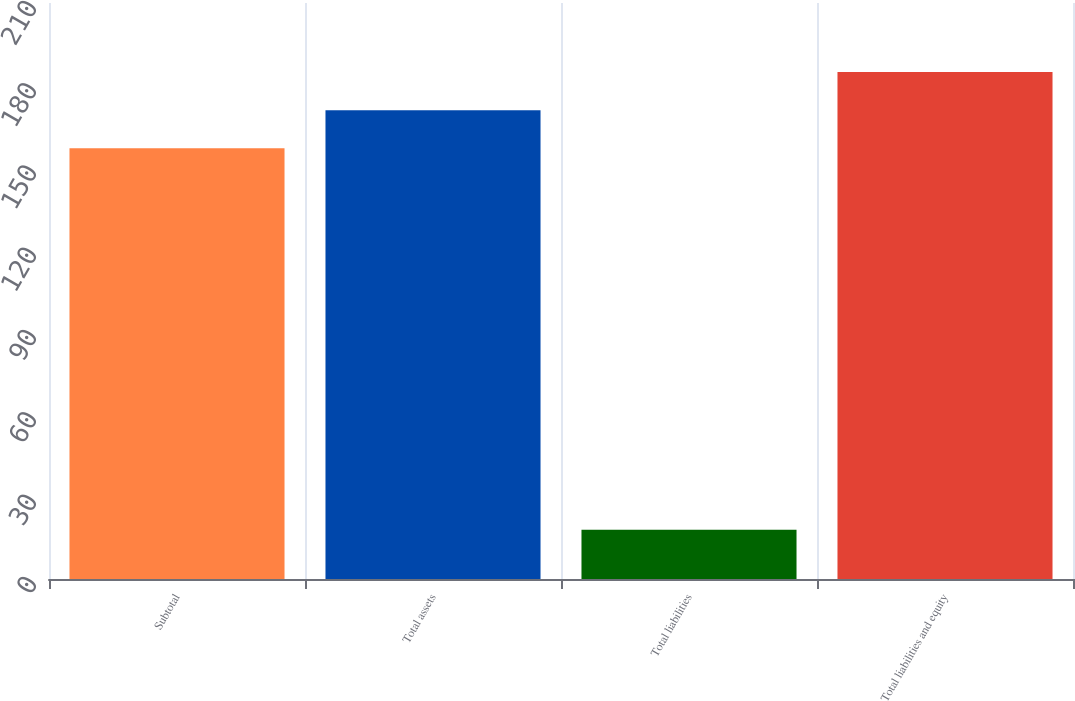<chart> <loc_0><loc_0><loc_500><loc_500><bar_chart><fcel>Subtotal<fcel>Total assets<fcel>Total liabilities<fcel>Total liabilities and equity<nl><fcel>157<fcel>170.9<fcel>18<fcel>184.8<nl></chart> 